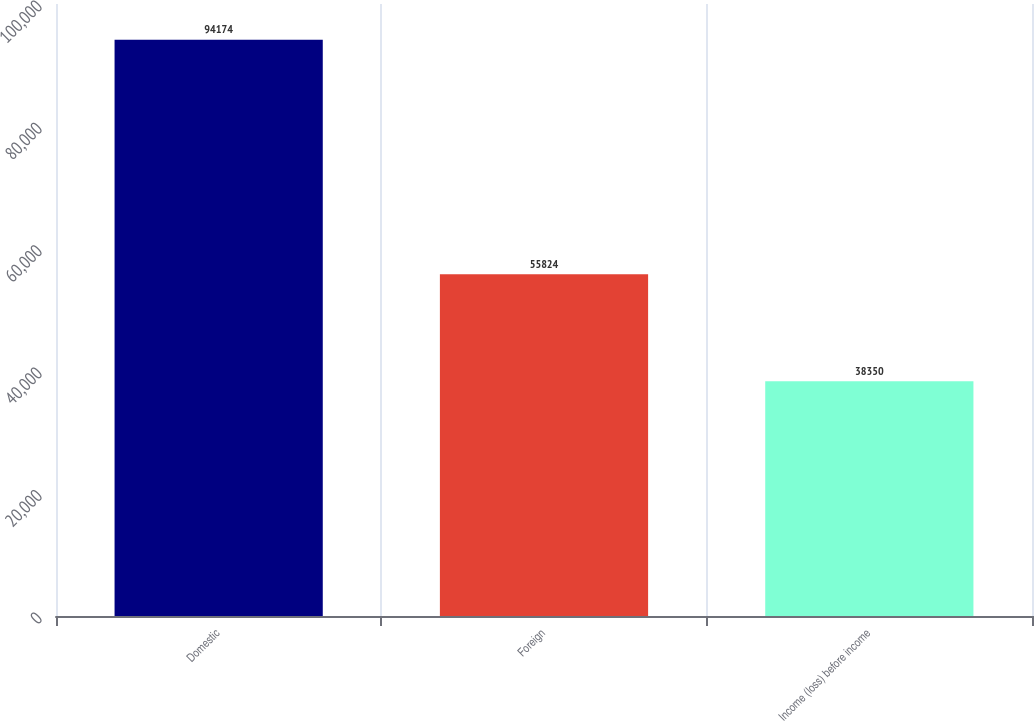Convert chart to OTSL. <chart><loc_0><loc_0><loc_500><loc_500><bar_chart><fcel>Domestic<fcel>Foreign<fcel>Income (loss) before income<nl><fcel>94174<fcel>55824<fcel>38350<nl></chart> 